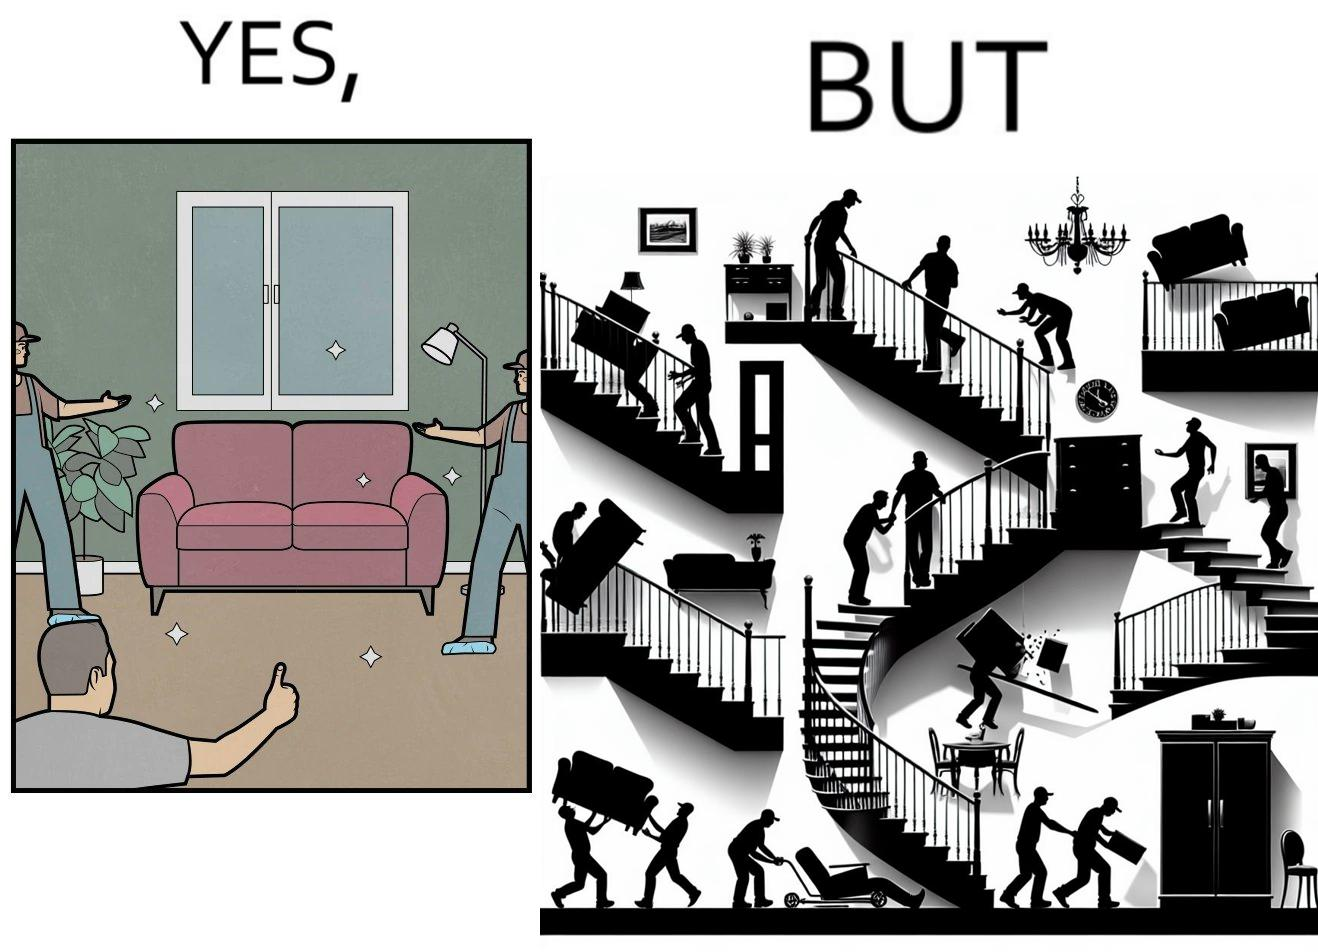Is there satirical content in this image? Yes, this image is satirical. 